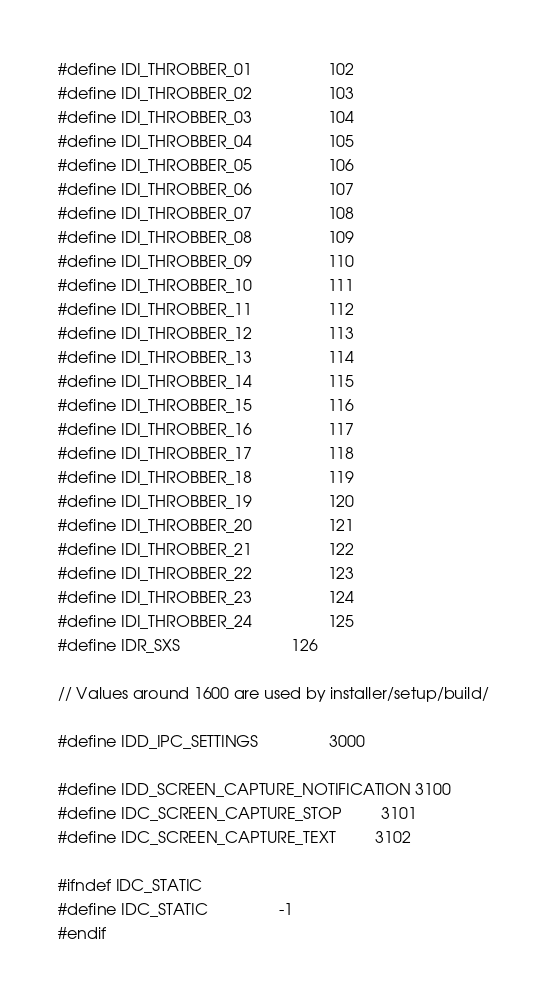Convert code to text. <code><loc_0><loc_0><loc_500><loc_500><_C_>
#define IDI_THROBBER_01                 102
#define IDI_THROBBER_02                 103
#define IDI_THROBBER_03                 104
#define IDI_THROBBER_04                 105
#define IDI_THROBBER_05                 106
#define IDI_THROBBER_06                 107
#define IDI_THROBBER_07                 108
#define IDI_THROBBER_08                 109
#define IDI_THROBBER_09                 110
#define IDI_THROBBER_10                 111
#define IDI_THROBBER_11                 112
#define IDI_THROBBER_12                 113
#define IDI_THROBBER_13                 114
#define IDI_THROBBER_14                 115
#define IDI_THROBBER_15                 116
#define IDI_THROBBER_16                 117
#define IDI_THROBBER_17                 118
#define IDI_THROBBER_18                 119
#define IDI_THROBBER_19                 120
#define IDI_THROBBER_20                 121
#define IDI_THROBBER_21                 122
#define IDI_THROBBER_22                 123
#define IDI_THROBBER_23                 124
#define IDI_THROBBER_24                 125
#define IDR_SXS                         126

// Values around 1600 are used by installer/setup/build/

#define IDD_IPC_SETTINGS                3000

#define IDD_SCREEN_CAPTURE_NOTIFICATION 3100
#define IDC_SCREEN_CAPTURE_STOP         3101
#define IDC_SCREEN_CAPTURE_TEXT         3102

#ifndef IDC_STATIC
#define IDC_STATIC                -1
#endif
</code> 